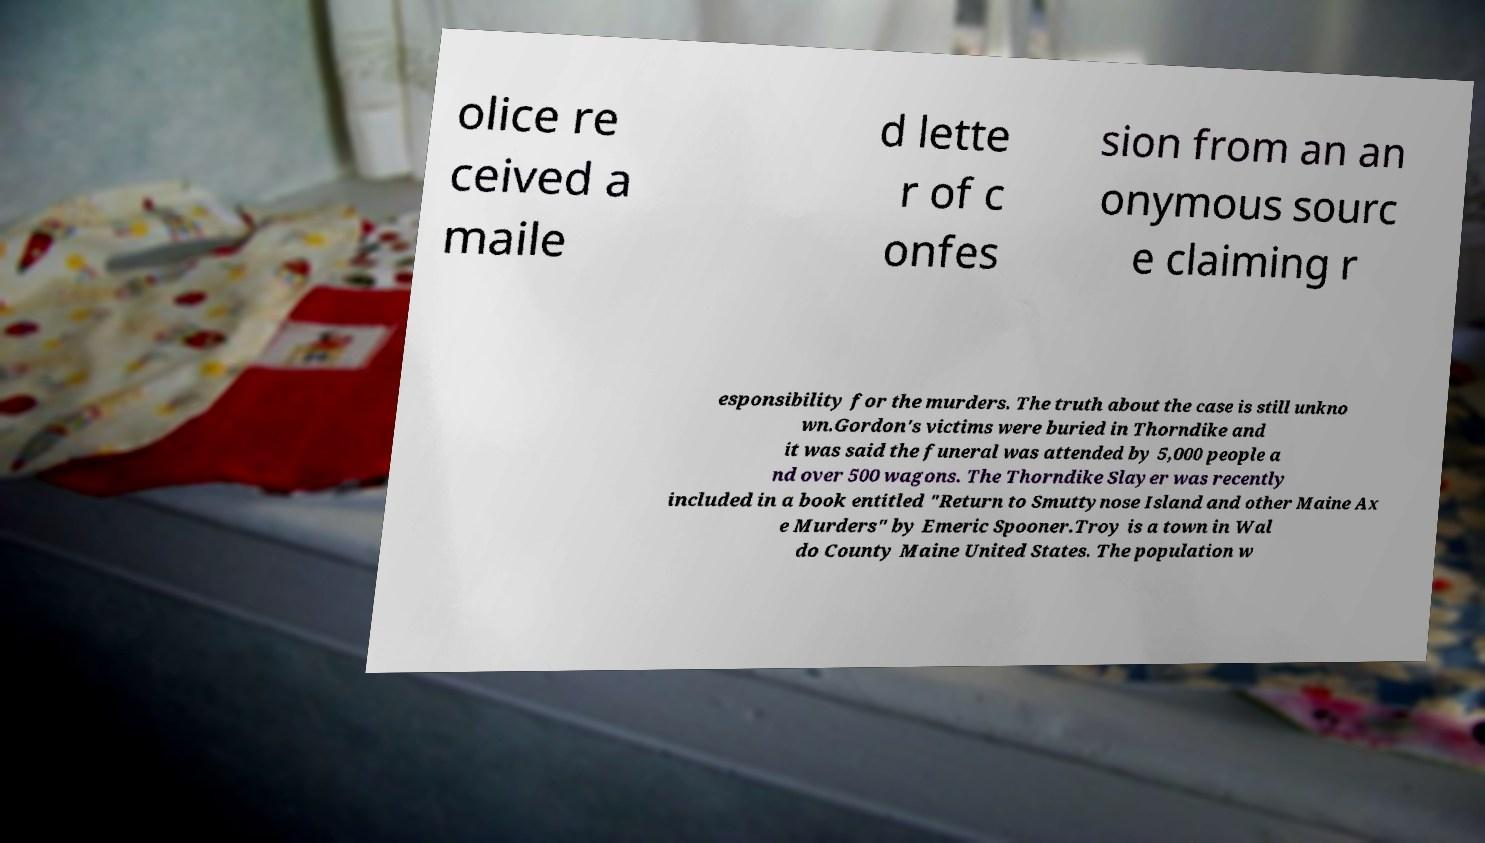Please identify and transcribe the text found in this image. olice re ceived a maile d lette r of c onfes sion from an an onymous sourc e claiming r esponsibility for the murders. The truth about the case is still unkno wn.Gordon's victims were buried in Thorndike and it was said the funeral was attended by 5,000 people a nd over 500 wagons. The Thorndike Slayer was recently included in a book entitled "Return to Smuttynose Island and other Maine Ax e Murders" by Emeric Spooner.Troy is a town in Wal do County Maine United States. The population w 